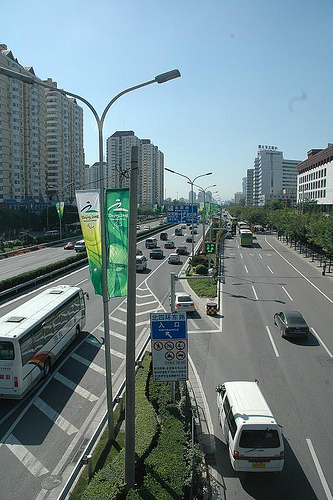<image>
Is the bus behind the streetlamp? No. The bus is not behind the streetlamp. From this viewpoint, the bus appears to be positioned elsewhere in the scene. 